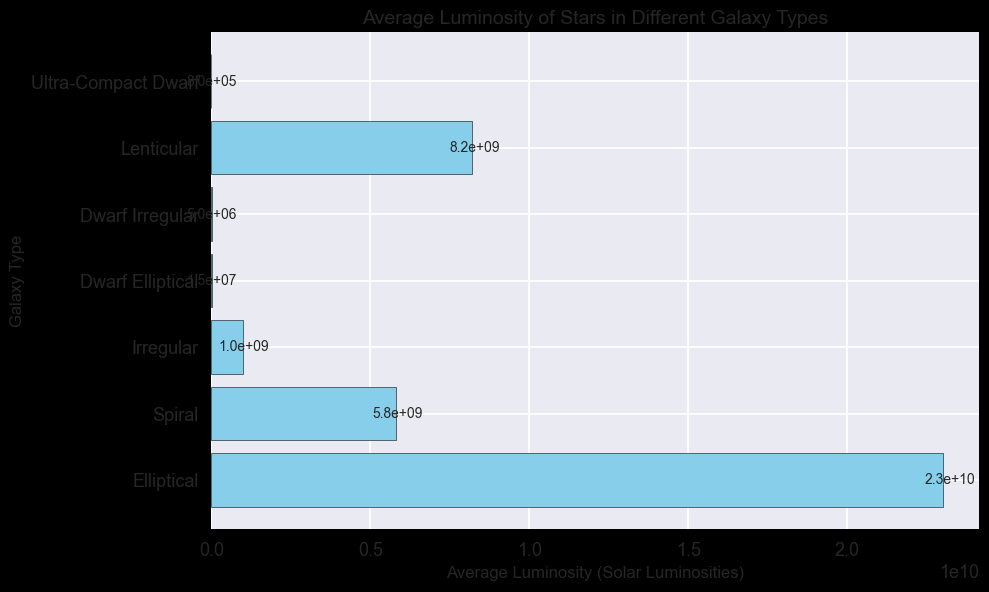Which galaxy type has the highest average luminosity? The galaxy type with the highest average luminosity is the galaxy type whose bar is the longest in the horizontal bar chart. In the figure, the 'Elliptical' galaxy is the one with the longest bar (2.3e10 solar luminosities).
Answer: Elliptical How does the average luminosity of Spiral galaxies compare to that of Irregular galaxies? To compare, observe the lengths of the bars for Spiral and Irregular galaxies. The average luminosity for Spiral galaxies is 5.8e9, while for Irregular galaxies it is 1.0e9. Clearly, Spiral galaxies have higher luminosity than Irregular galaxies.
Answer: Higher What is the combined average luminosity of Dwarf Elliptical and Dwarf Irregular galaxies? To find the combined average luminosity, add the luminosities of Dwarf Elliptical and Dwarf Irregular galaxies: 1.5e7 + 5.0e6 = 2.0e7.
Answer: 2.0e7 Which galaxy type has the lowest average luminosity, and what is its value? Identify the shortest bar in the chart to find the galaxy type with the lowest luminosity. The 'Ultra-Compact Dwarf' galaxy has the shortest bar with an average luminosity of 8.0e5.
Answer: Ultra-Compact Dwarf, 8.0e5 What is the difference in average luminosity between Lenticular and Ultra-Compact Dwarf galaxies? Subtract the luminosity of Ultra-Compact Dwarf galaxies from the luminosity of Lenticular galaxies: 8.2e9 - 8.0e5 = 8.1992e9.
Answer: 8.1992e9 Which two galaxy types have the closest average luminosity values? Compare the lengths of the bars visually to identify the two galaxy types with the closest average luminosity values. 'Lenticular' and 'Spiral' galaxies have the closest values with 8.2e9 and 5.8e9 respectively.
Answer: Lenticular and Spiral What is the ratio of average luminosity between Elliptical and Lenticular galaxies? Divide the average luminosity of Elliptical galaxies by that of Lenticular galaxies: 2.3e10 / 8.2e9 ≈ 2.80.
Answer: 2.80 